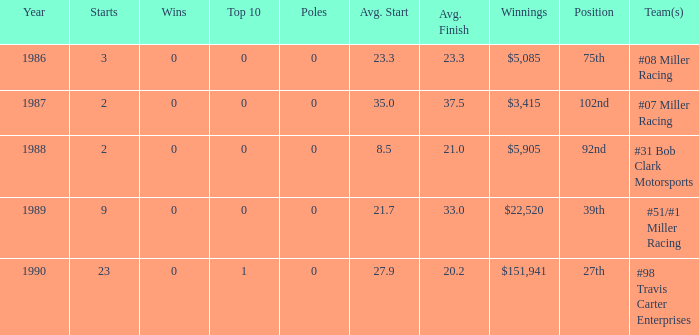What racing team/s had the 92nd position? #31 Bob Clark Motorsports. 